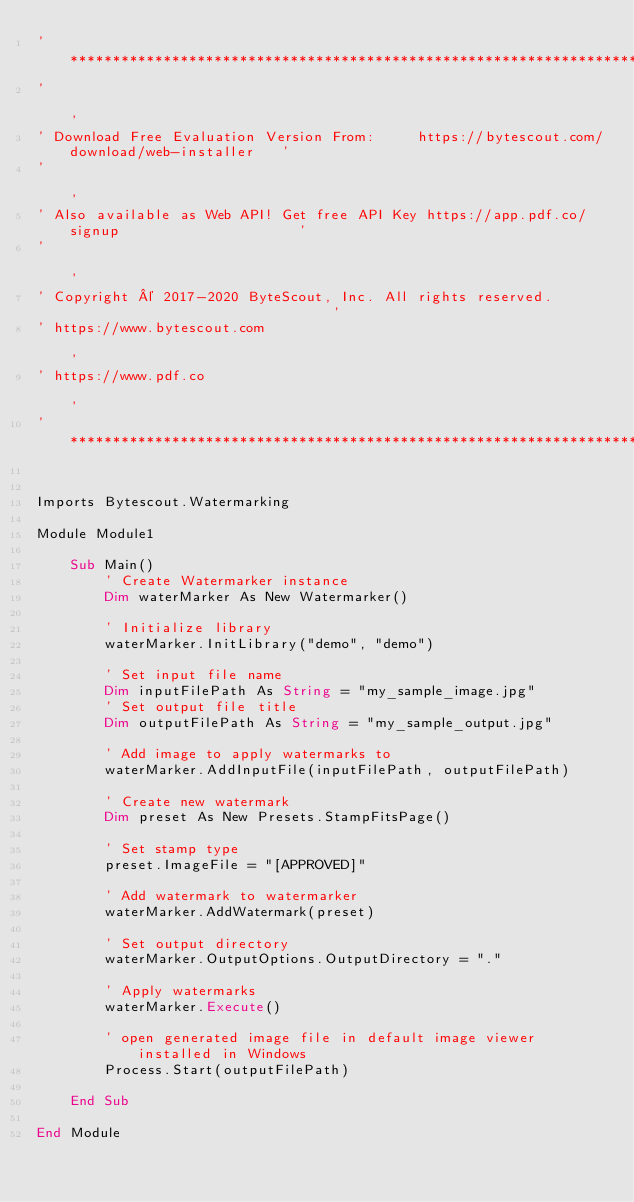Convert code to text. <code><loc_0><loc_0><loc_500><loc_500><_VisualBasic_>'*******************************************************************************************'
'                                                                                           '
' Download Free Evaluation Version From:     https://bytescout.com/download/web-installer   '
'                                                                                           '
' Also available as Web API! Get free API Key https://app.pdf.co/signup                     '
'                                                                                           '
' Copyright © 2017-2020 ByteScout, Inc. All rights reserved.                                '
' https://www.bytescout.com                                                                 '
' https://www.pdf.co                                                                        '
'*******************************************************************************************'


Imports Bytescout.Watermarking

Module Module1

    Sub Main()
        ' Create Watermarker instance
        Dim waterMarker As New Watermarker()

        ' Initialize library
        waterMarker.InitLibrary("demo", "demo")

        ' Set input file name
        Dim inputFilePath As String = "my_sample_image.jpg"
        ' Set output file title
        Dim outputFilePath As String = "my_sample_output.jpg"

        ' Add image to apply watermarks to
        waterMarker.AddInputFile(inputFilePath, outputFilePath)

        ' Create new watermark
        Dim preset As New Presets.StampFitsPage()

        ' Set stamp type
        preset.ImageFile = "[APPROVED]"

        ' Add watermark to watermarker
        waterMarker.AddWatermark(preset)

        ' Set output directory
        waterMarker.OutputOptions.OutputDirectory = "."

        ' Apply watermarks
        waterMarker.Execute()

        ' open generated image file in default image viewer installed in Windows
        Process.Start(outputFilePath)

    End Sub

End Module
</code> 